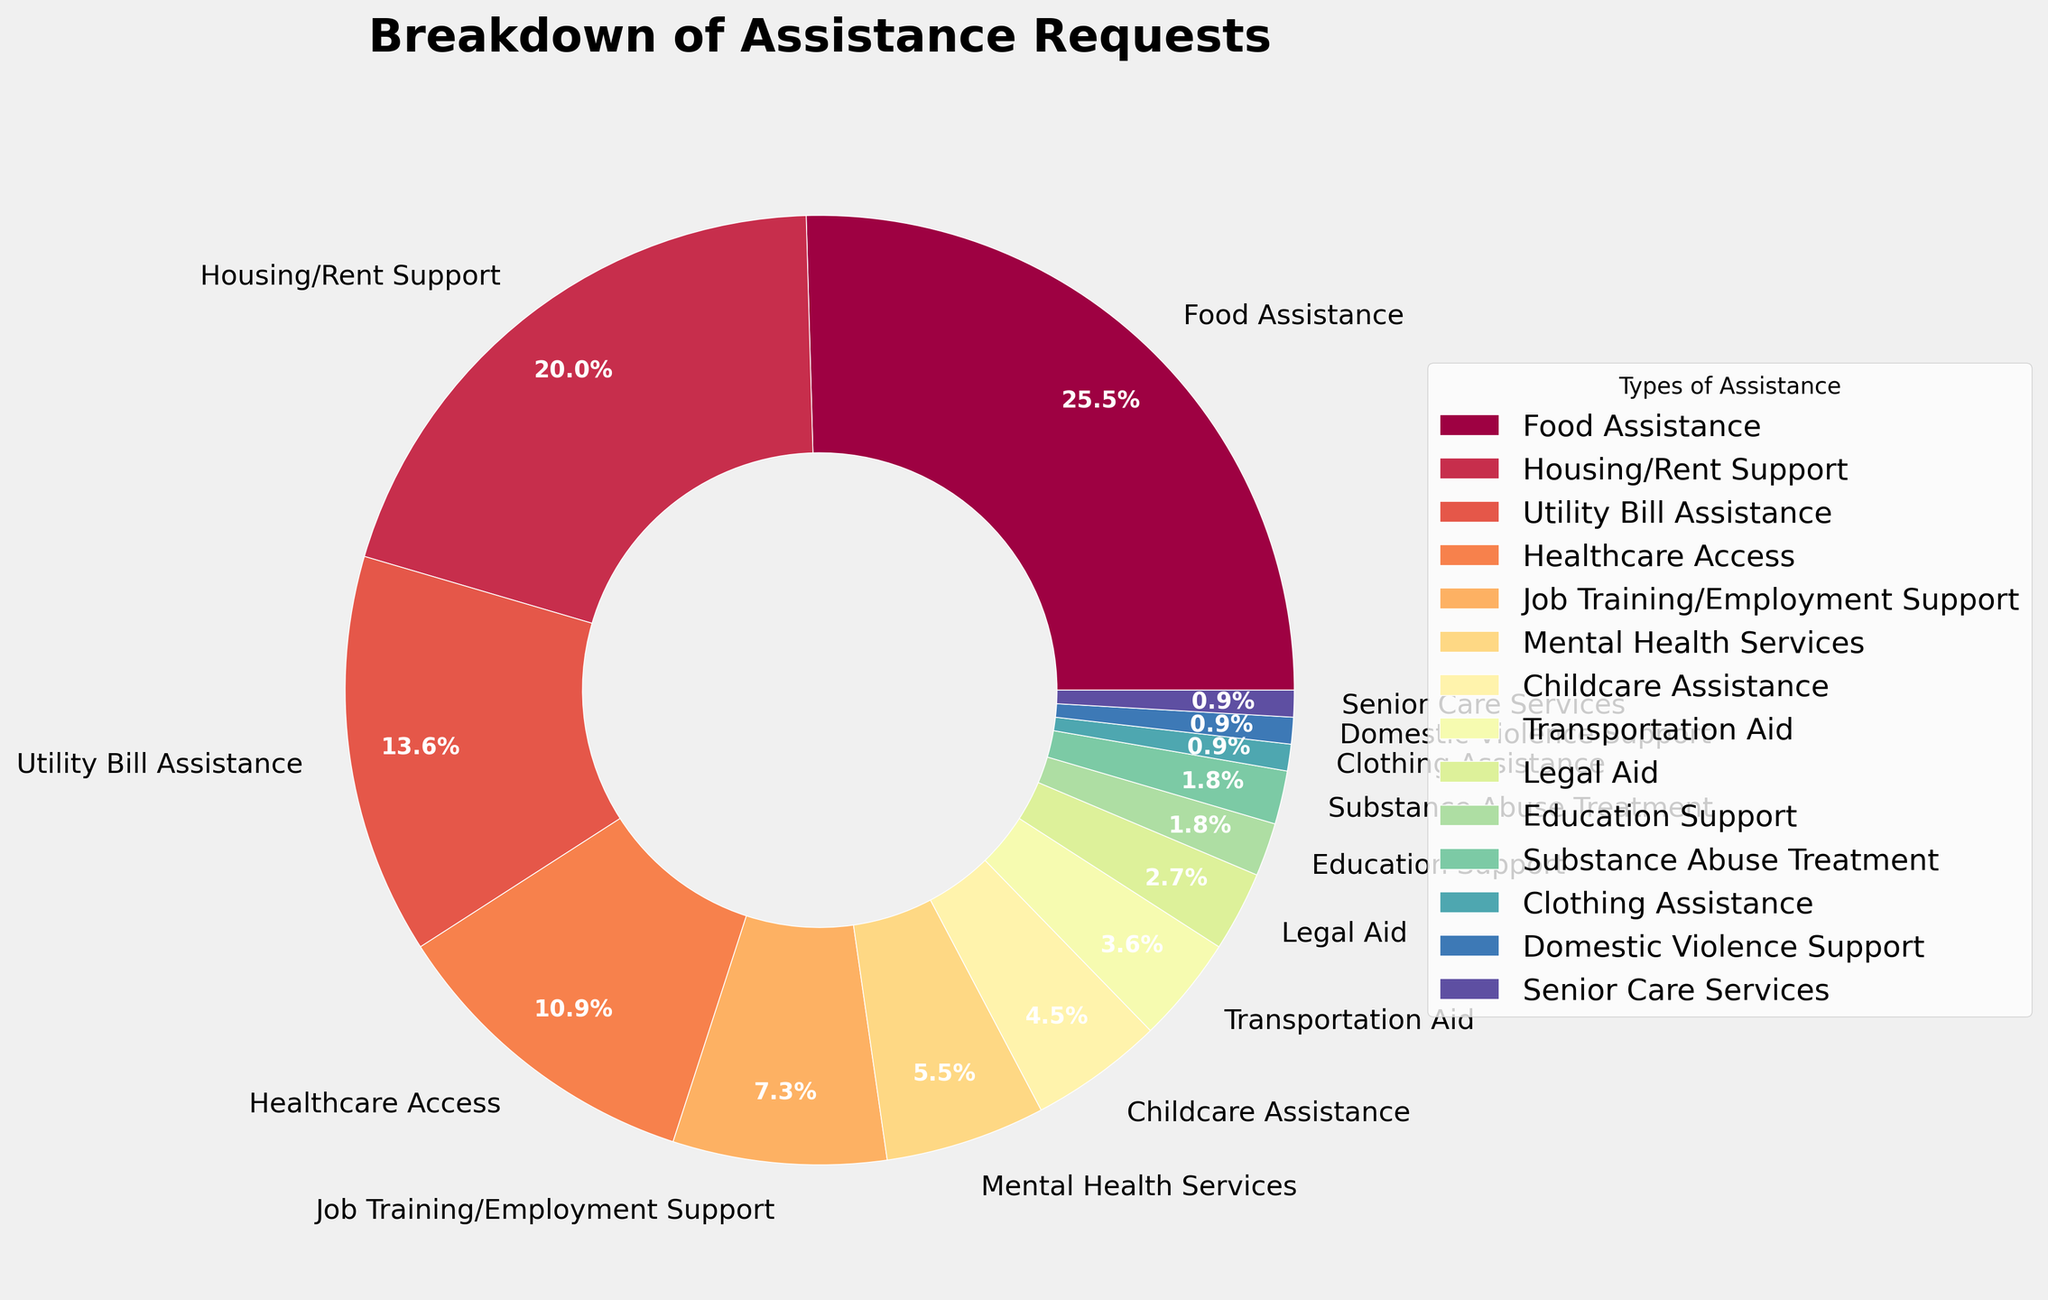Which type of assistance has the highest percentage of requests? By looking at the chart, the largest wedge represents the type of assistance with the highest percentage, which is Food Assistance.
Answer: Food Assistance How much more percentage does Food Assistance have compared to Utility Bill Assistance? Food Assistance has 28%, and Utility Bill Assistance has 15%. The difference is calculated as 28% - 15% = 13%.
Answer: 13% What are the combined percentages of Housing/Rent Support and Healthcare Access? Housing/Rent Support is 22%, and Healthcare Access is 12%. Their combined percentage is 22% + 12% = 34%.
Answer: 34% Which type of assistance has a smaller percentage, Transportation Aid or Job Training/Employment Support? By comparing the sizes of the wedges, Job Training/Employment Support is 8%, while Transportation Aid is 4%, so Transportation Aid has a smaller percentage.
Answer: Transportation Aid What is the combined percentage of all types of assistance requests that are 5% or less? The types of assistance with 5% or less are Childcare Assistance (5%), Transportation Aid (4%), Legal Aid (3%), Education Support (2%), Substance Abuse Treatment (2%), Clothing Assistance (1%), Domestic Violence Support (1%), and Senior Care Services (1%). Adding them up: 5% + 4% + 3% + 2% + 2% + 1% + 1% + 1% = 19%.
Answer: 19% How many types of assistance are represented with a percentage of 10% or higher? Types of assistance with 10% or higher are Food Assistance (28%), Housing/Rent Support (22%), Utility Bill Assistance (15%), and Healthcare Access (12%). Counting these, there are 4.
Answer: 4 Which assistance type has the lowest request percentage? The smallest wedges in the chart indicate Domestic Violence Support, Senior Care Services, and Clothing Assistance, each at 1%.
Answer: Domestic Violence Support, Senior Care Services, Clothing Assistance Which is greater, the percentage for Mental Health Services or the combined percentage of Education Support and Substance Abuse Treatment? Mental Health Services is at 6%, while Education Support and Substance Abuse Treatment are both 2%, their combined percentage is 2% + 2% = 4%. So, 6% is greater than 4%.
Answer: Mental Health Services What is the average percentage of requests for Housing/Rent Support, Utility Bill Assistance, and Healthcare Access? Summing up the percentages for Housing/Rent Support (22%), Utility Bill Assistance (15%), and Healthcare Access (12%) gives 22% + 15% + 12% = 49%. The average is 49% / 3 ≈ 16.33%.
Answer: 16.33% Among the types of assistance related to basic necessities (Food, Housing/Rent, Utility Bills), which has the smallest percentage of requests? The three types are Food Assistance (28%), Housing/Rent Support (22%), and Utility Bill Assistance (15%). The smallest percentage among them is Utility Bill Assistance.
Answer: Utility Bill Assistance 